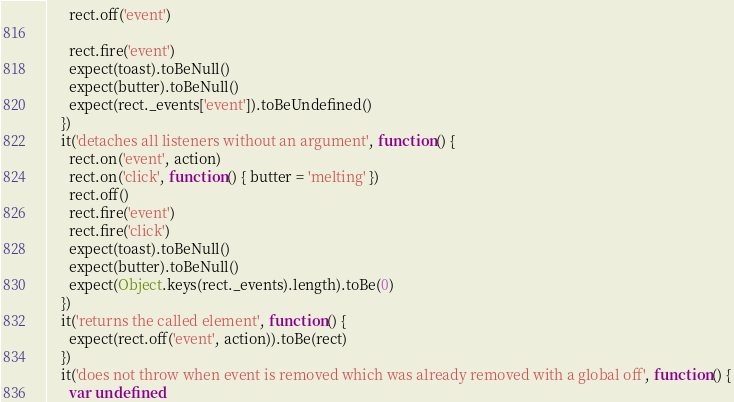<code> <loc_0><loc_0><loc_500><loc_500><_JavaScript_>      rect.off('event')

      rect.fire('event')
      expect(toast).toBeNull()
      expect(butter).toBeNull()
      expect(rect._events['event']).toBeUndefined()
    })
    it('detaches all listeners without an argument', function() {
      rect.on('event', action)
      rect.on('click', function() { butter = 'melting' })
      rect.off()
      rect.fire('event')
      rect.fire('click')
      expect(toast).toBeNull()
      expect(butter).toBeNull()
      expect(Object.keys(rect._events).length).toBe(0)
    })
    it('returns the called element', function() {
      expect(rect.off('event', action)).toBe(rect)
    })
    it('does not throw when event is removed which was already removed with a global off', function() {
      var undefined
</code> 